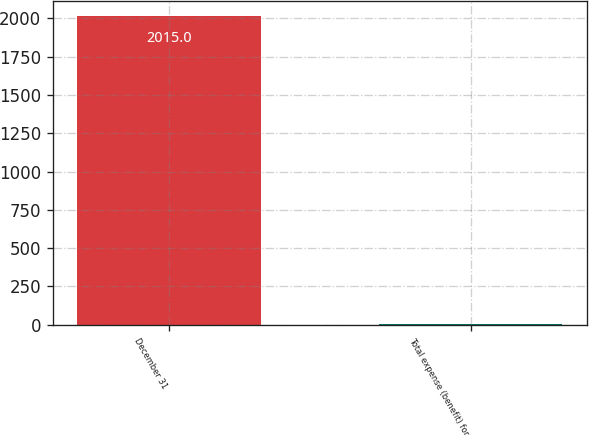Convert chart to OTSL. <chart><loc_0><loc_0><loc_500><loc_500><bar_chart><fcel>December 31<fcel>Total expense (benefit) for<nl><fcel>2015<fcel>2<nl></chart> 